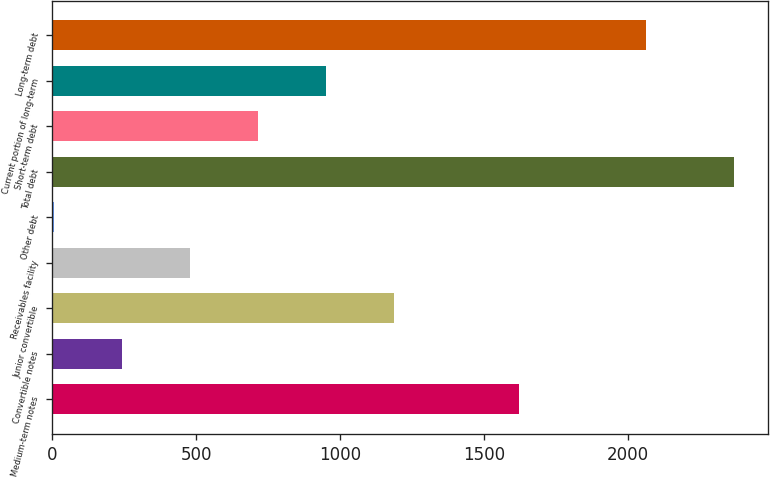<chart> <loc_0><loc_0><loc_500><loc_500><bar_chart><fcel>Medium-term notes<fcel>Convertible notes<fcel>Junior convertible<fcel>Receivables facility<fcel>Other debt<fcel>Total debt<fcel>Short-term debt<fcel>Current portion of long-term<fcel>Long-term debt<nl><fcel>1623<fcel>243.82<fcel>1188.3<fcel>479.94<fcel>7.7<fcel>2368.9<fcel>716.06<fcel>952.18<fcel>2063.9<nl></chart> 